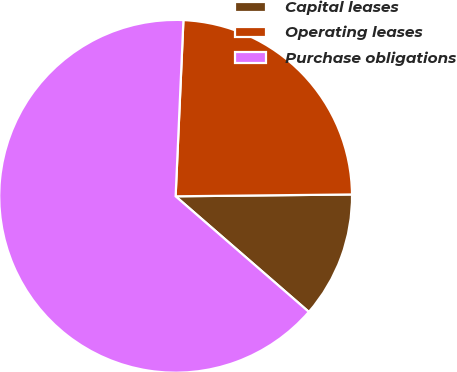Convert chart. <chart><loc_0><loc_0><loc_500><loc_500><pie_chart><fcel>Capital leases<fcel>Operating leases<fcel>Purchase obligations<nl><fcel>11.54%<fcel>24.13%<fcel>64.33%<nl></chart> 